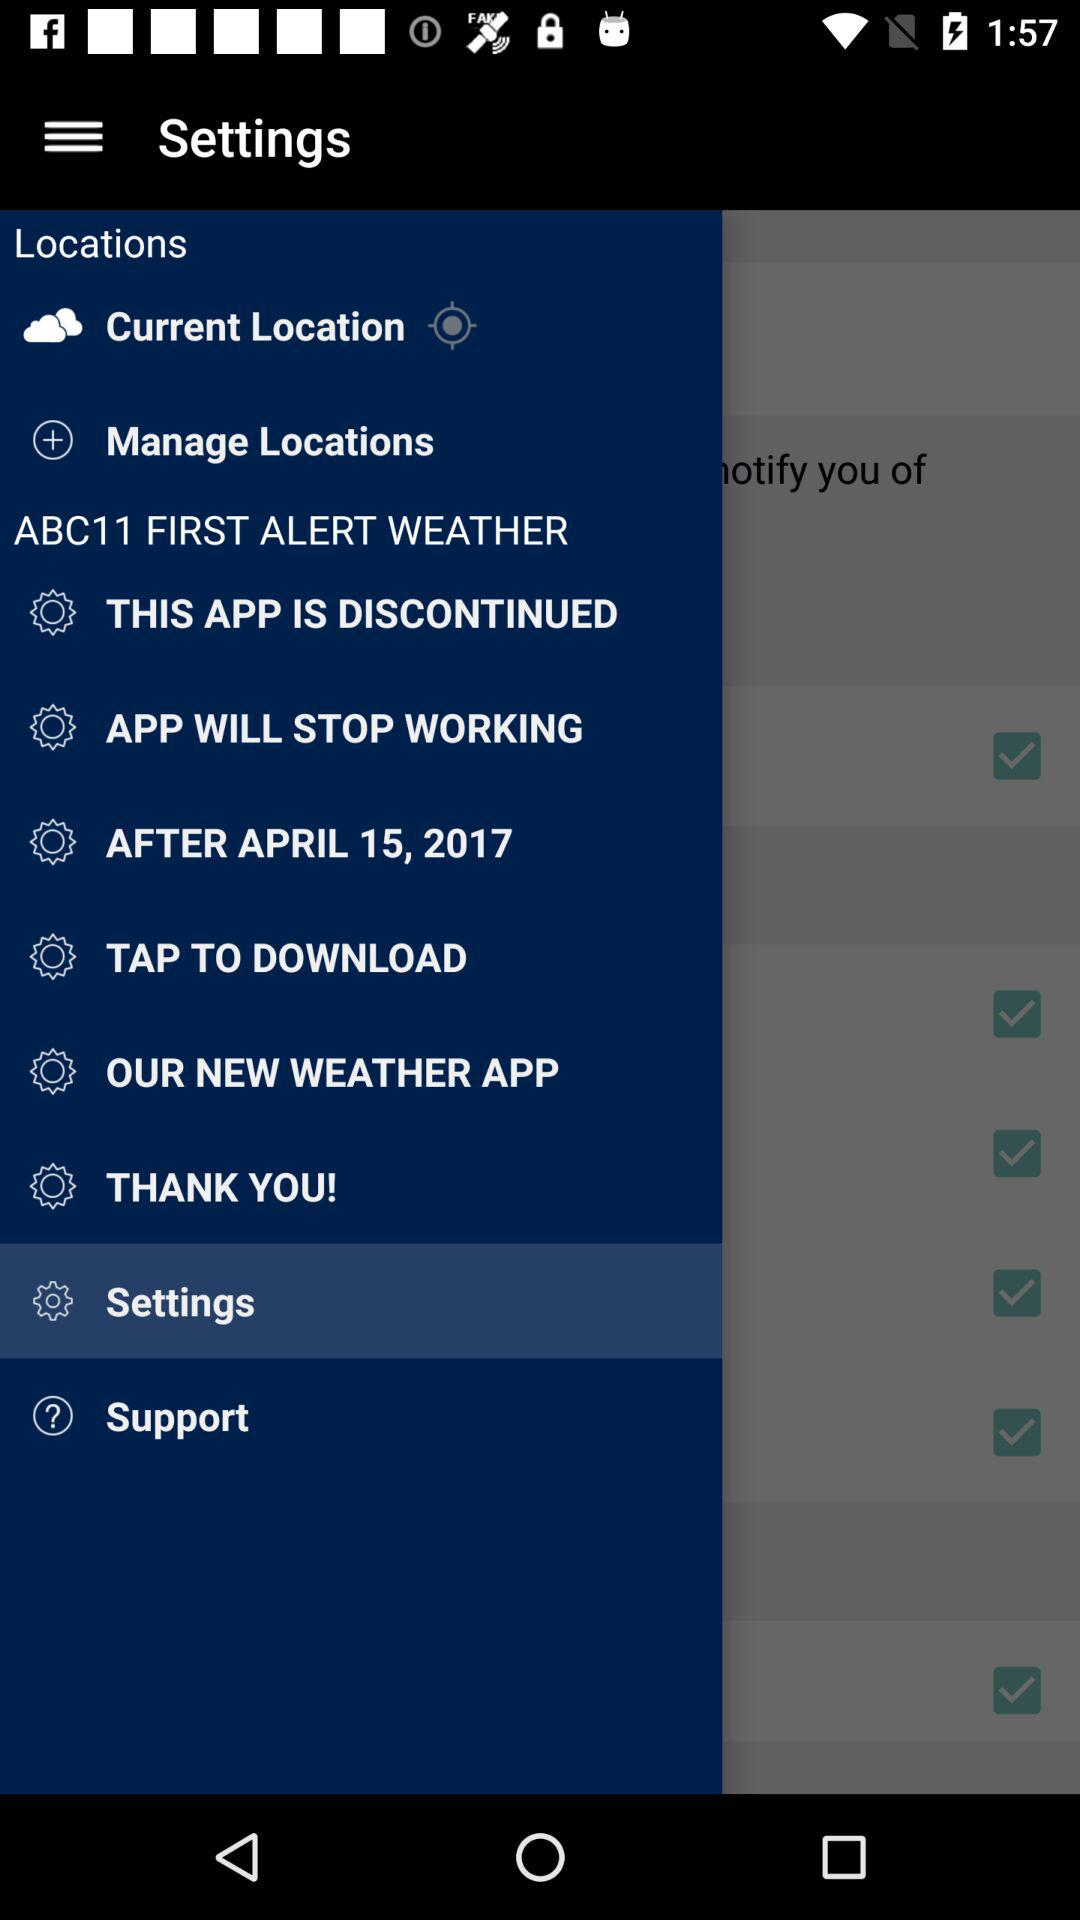What is the current location?
When the provided information is insufficient, respond with <no answer>. <no answer> 